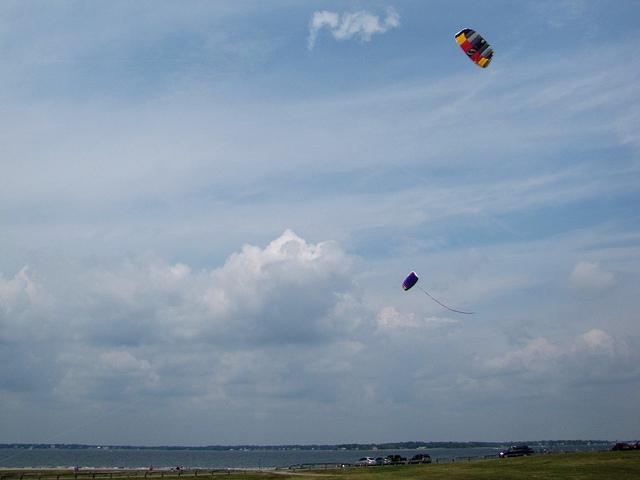What is on the sky?
Quick response, please. Kites. Is there a crane in the picture?
Quick response, please. No. Are the people on a beach?
Give a very brief answer. Yes. Is this a sunny day?
Quick response, please. No. Is the landscape flat?
Write a very short answer. Yes. Is the sky clear?
Concise answer only. No. Are there clouds in the sky?
Answer briefly. Yes. Is this taking place in a grassy field?
Short answer required. No. 